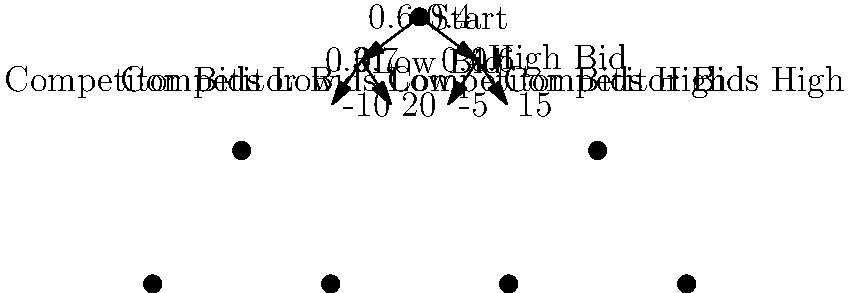As a sports agent, you're advising a professional athlete on their bidding strategy for an upcoming sports auction. The decision tree above represents the possible outcomes based on your client's and their competitor's bidding strategies. The probabilities of each scenario and the corresponding payoffs (in millions of dollars) are shown. What is the expected value of choosing the "High Bid" strategy, and should your client pursue this option? To solve this problem, we'll use the concept of expected value from game theory. Let's break it down step-by-step:

1. First, let's calculate the expected value of the "High Bid" strategy:

   a) If the competitor bids low (probability 0.4):
      Payoff = $-5$ million
   
   b) If the competitor bids high (probability 0.6):
      Payoff = $15$ million

   Expected Value (High Bid) = $(0.4 \times -5) + (0.6 \times 15)$
                              = $-2 + 9$
                              = $7$ million

2. Now, let's calculate the expected value of the "Low Bid" strategy for comparison:

   a) If the competitor bids low (probability 0.3):
      Payoff = $-10$ million
   
   b) If the competitor bids high (probability 0.7):
      Payoff = $20$ million

   Expected Value (Low Bid) = $(0.3 \times -10) + (0.7 \times 20)$
                             = $-3 + 14$
                             = $11$ million

3. Comparing the two strategies:
   - High Bid strategy: $7$ million expected value
   - Low Bid strategy: $11$ million expected value

4. Decision:
   Since the expected value of the Low Bid strategy ($11$ million) is higher than the High Bid strategy ($7$ million), your client should not pursue the High Bid option.
Answer: $7 million; No 